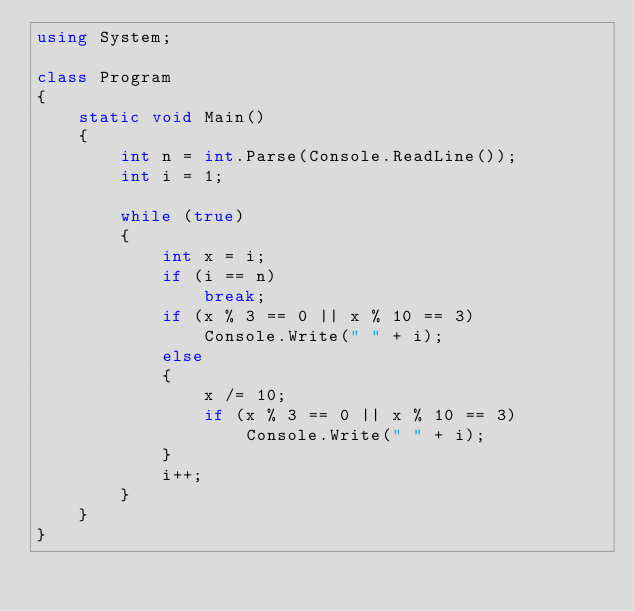Convert code to text. <code><loc_0><loc_0><loc_500><loc_500><_C#_>using System;

class Program
{
    static void Main()
    {
        int n = int.Parse(Console.ReadLine());
        int i = 1;

        while (true)
        {
            int x = i;
            if (i == n)
                break;
            if (x % 3 == 0 || x % 10 == 3)
                Console.Write(" " + i);
            else
            {
                x /= 10;
                if (x % 3 == 0 || x % 10 == 3)
                    Console.Write(" " + i);
            }
            i++;
        }
    }
}</code> 